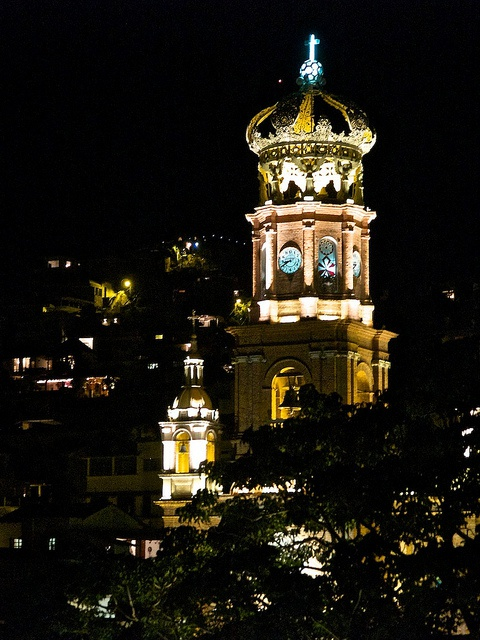Describe the objects in this image and their specific colors. I can see clock in black, gray, white, and teal tones, clock in black, lightblue, white, and teal tones, and clock in black, ivory, darkgray, and gray tones in this image. 